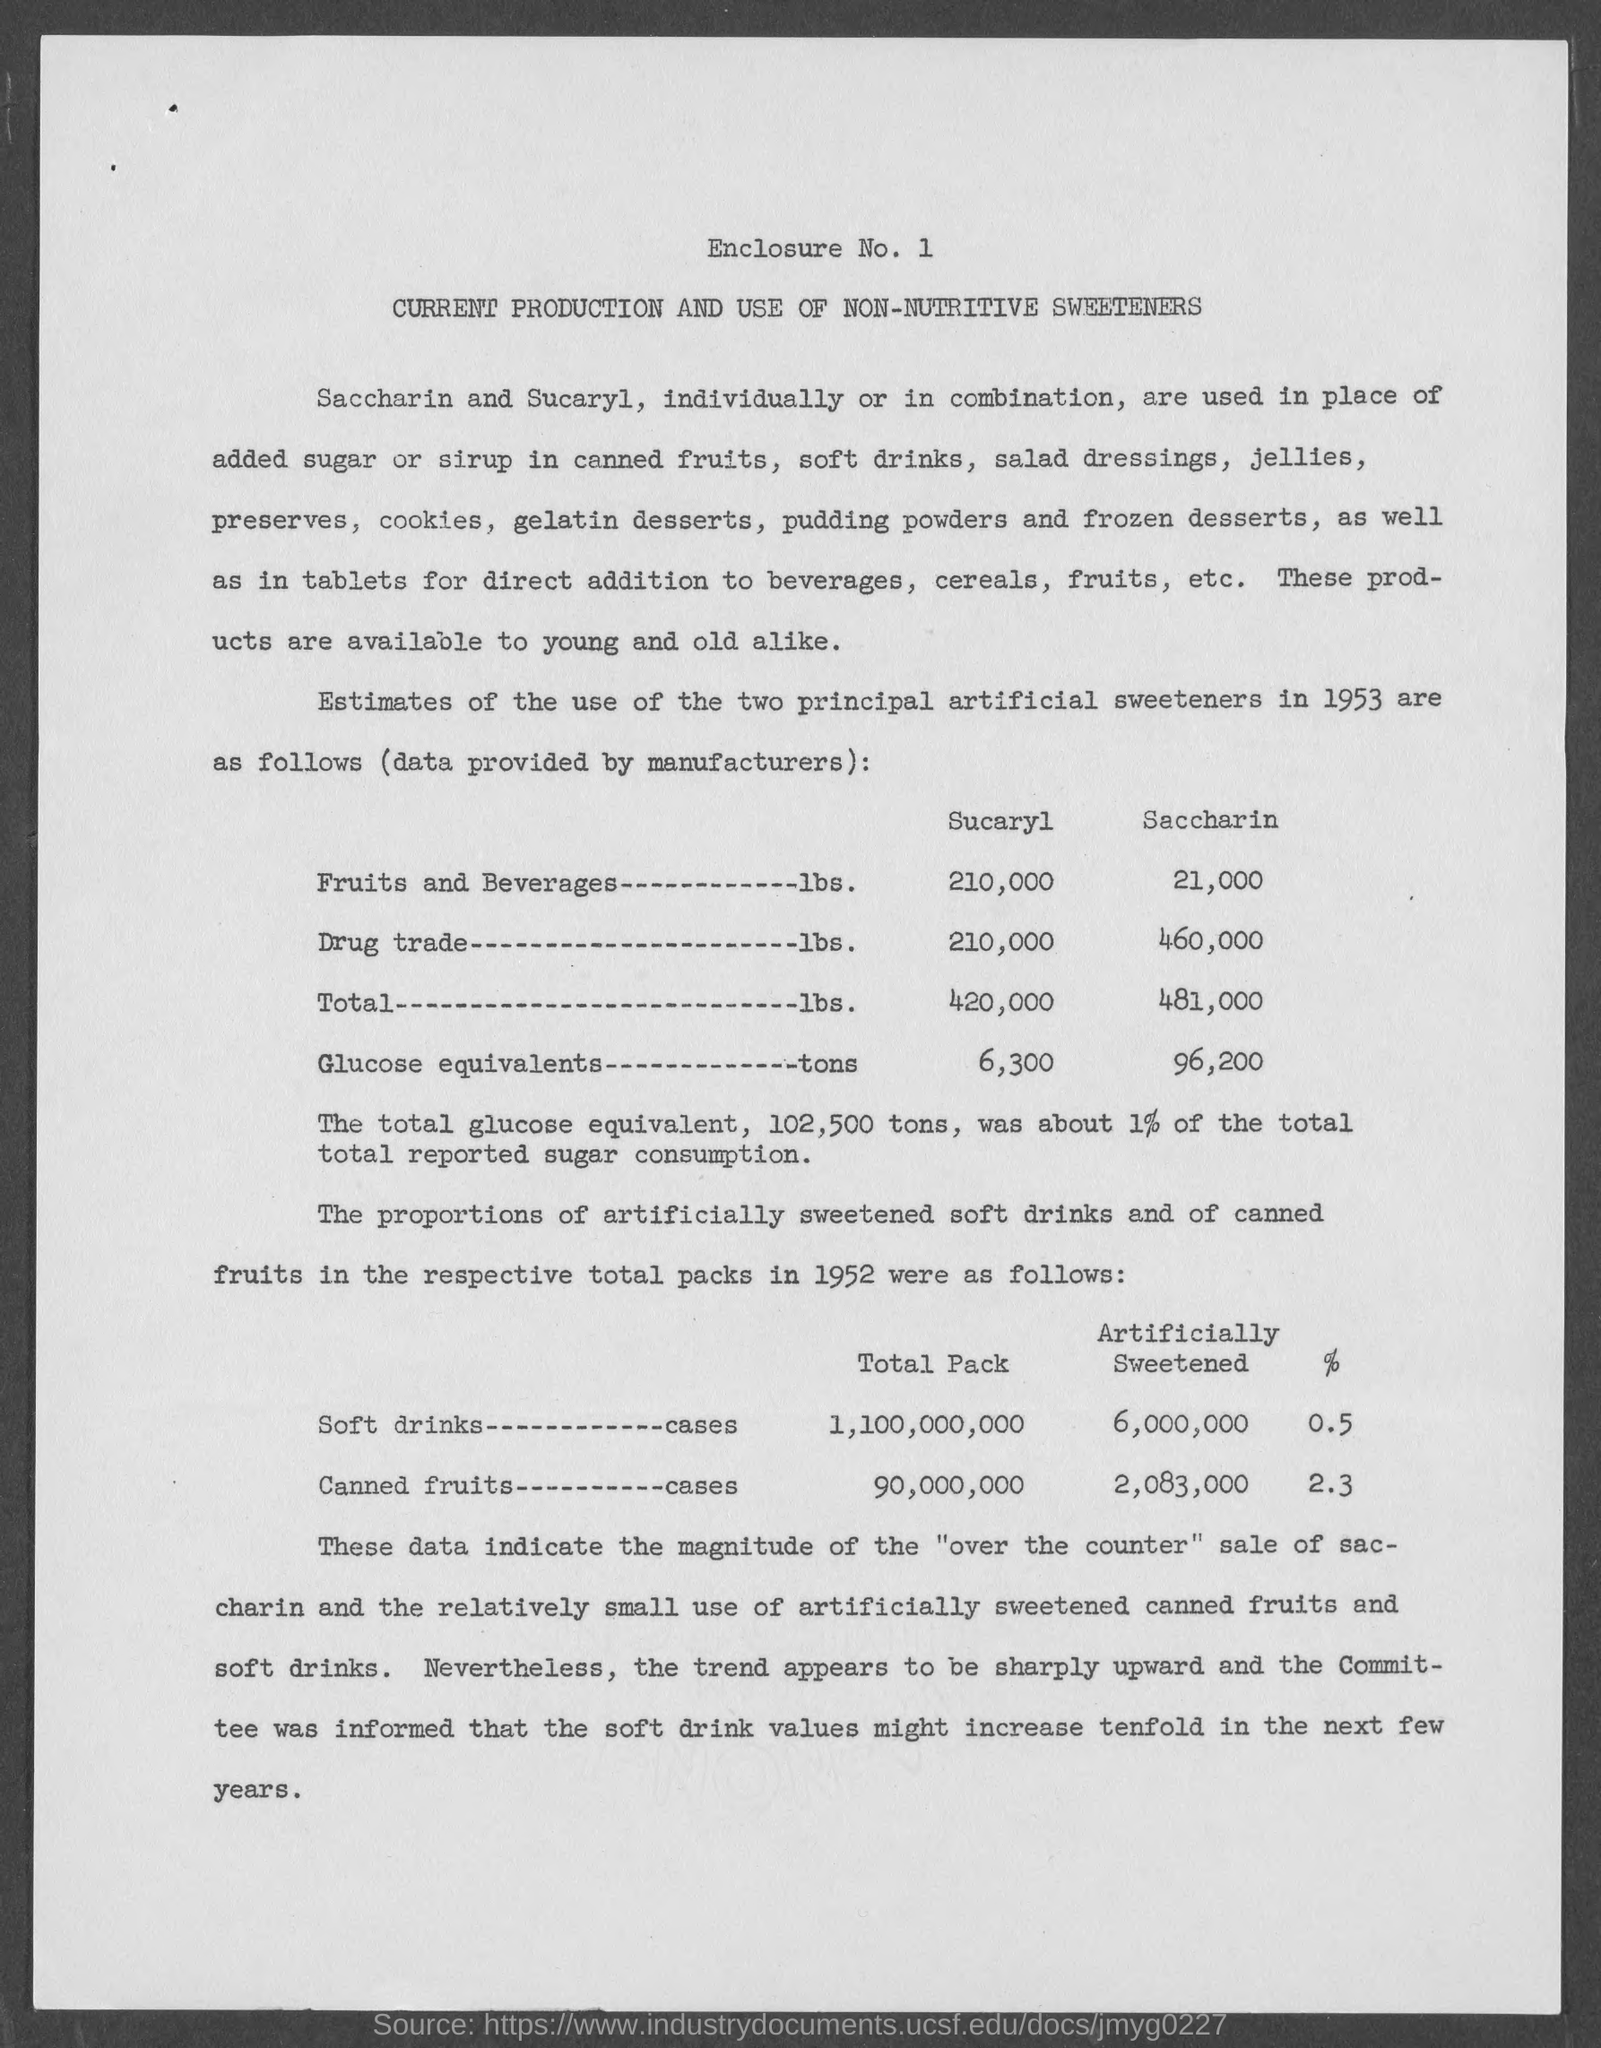How many lbs of  Sucaryl is added in Fruits and Beverages ?
Keep it short and to the point. 210,000. How many tons of Sucaryl is in  Glucose Equivalents?
Provide a short and direct response. 6,300. How many tons of Saccharin is in  Glucose Equivalents?
Offer a terse response. 96,200. How many tons of total glucose equivalent is about 1% of the total reported sugar consumption?
Your answer should be compact. 102,500. 